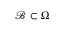Convert formula to latex. <formula><loc_0><loc_0><loc_500><loc_500>{ \mathcal { B } } \subset { \Omega }</formula> 